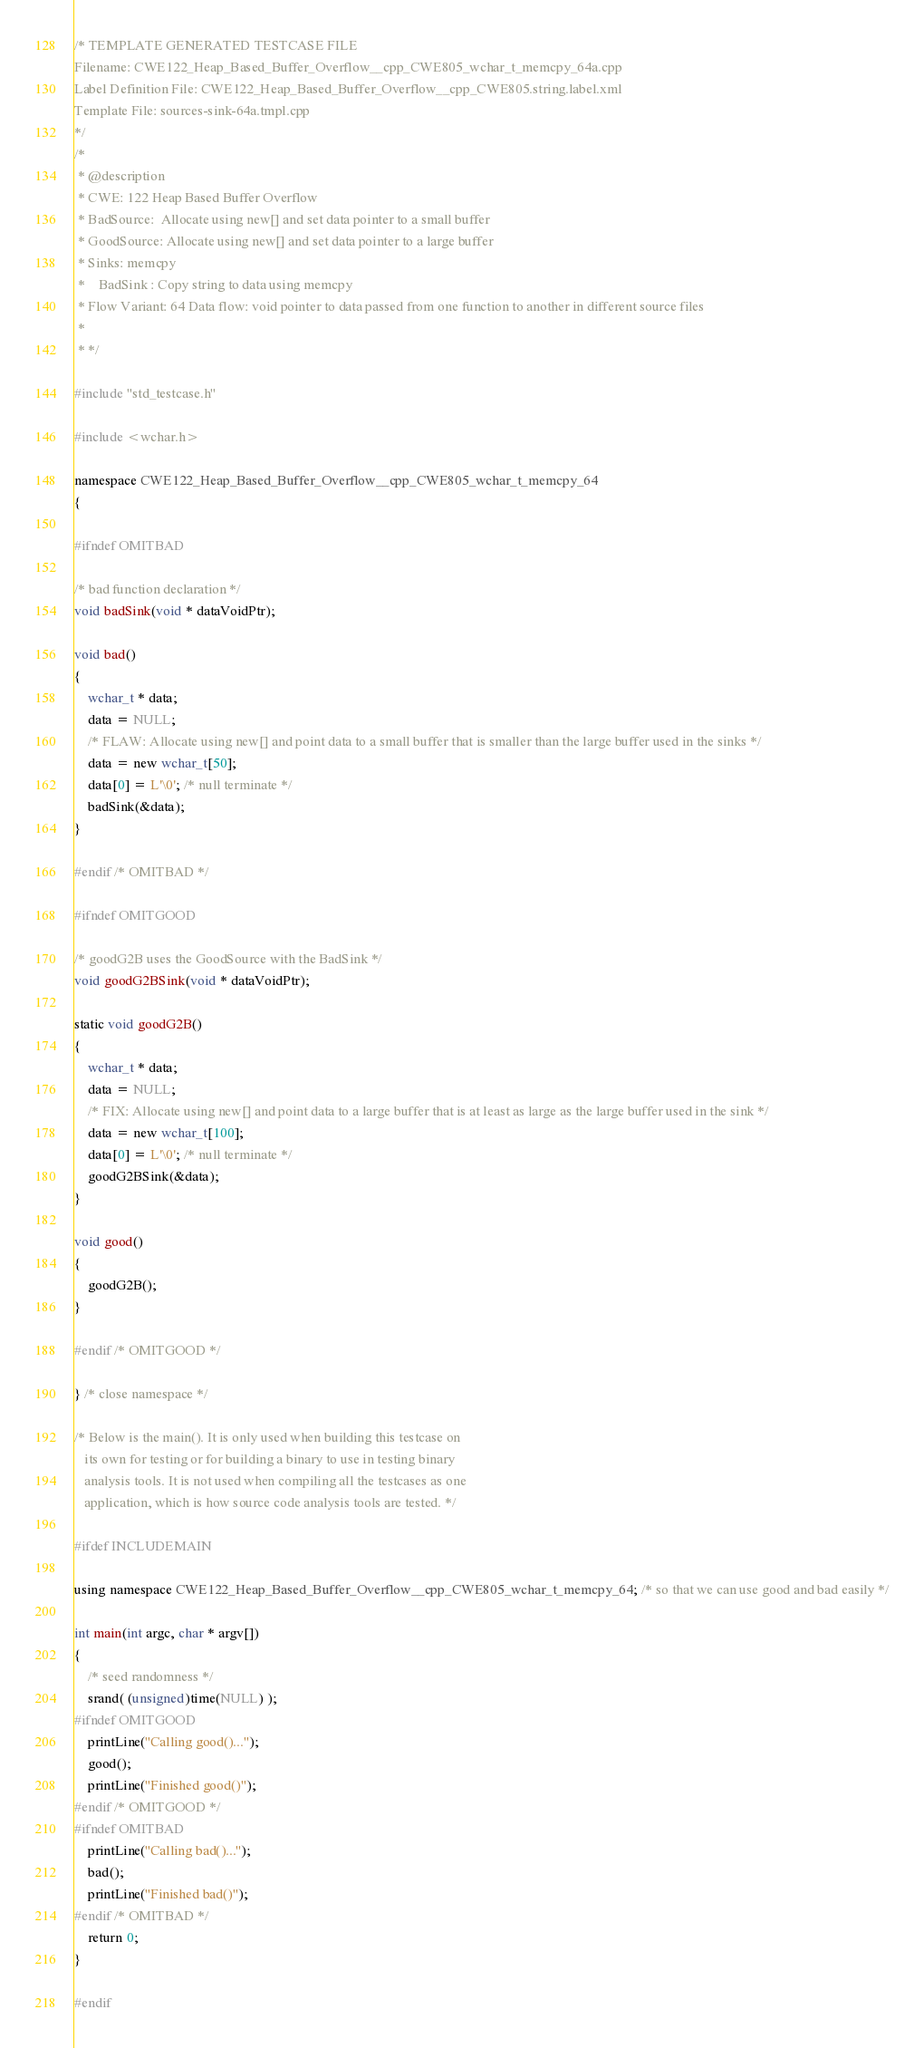<code> <loc_0><loc_0><loc_500><loc_500><_C++_>/* TEMPLATE GENERATED TESTCASE FILE
Filename: CWE122_Heap_Based_Buffer_Overflow__cpp_CWE805_wchar_t_memcpy_64a.cpp
Label Definition File: CWE122_Heap_Based_Buffer_Overflow__cpp_CWE805.string.label.xml
Template File: sources-sink-64a.tmpl.cpp
*/
/*
 * @description
 * CWE: 122 Heap Based Buffer Overflow
 * BadSource:  Allocate using new[] and set data pointer to a small buffer
 * GoodSource: Allocate using new[] and set data pointer to a large buffer
 * Sinks: memcpy
 *    BadSink : Copy string to data using memcpy
 * Flow Variant: 64 Data flow: void pointer to data passed from one function to another in different source files
 *
 * */

#include "std_testcase.h"

#include <wchar.h>

namespace CWE122_Heap_Based_Buffer_Overflow__cpp_CWE805_wchar_t_memcpy_64
{

#ifndef OMITBAD

/* bad function declaration */
void badSink(void * dataVoidPtr);

void bad()
{
    wchar_t * data;
    data = NULL;
    /* FLAW: Allocate using new[] and point data to a small buffer that is smaller than the large buffer used in the sinks */
    data = new wchar_t[50];
    data[0] = L'\0'; /* null terminate */
    badSink(&data);
}

#endif /* OMITBAD */

#ifndef OMITGOOD

/* goodG2B uses the GoodSource with the BadSink */
void goodG2BSink(void * dataVoidPtr);

static void goodG2B()
{
    wchar_t * data;
    data = NULL;
    /* FIX: Allocate using new[] and point data to a large buffer that is at least as large as the large buffer used in the sink */
    data = new wchar_t[100];
    data[0] = L'\0'; /* null terminate */
    goodG2BSink(&data);
}

void good()
{
    goodG2B();
}

#endif /* OMITGOOD */

} /* close namespace */

/* Below is the main(). It is only used when building this testcase on
   its own for testing or for building a binary to use in testing binary
   analysis tools. It is not used when compiling all the testcases as one
   application, which is how source code analysis tools are tested. */

#ifdef INCLUDEMAIN

using namespace CWE122_Heap_Based_Buffer_Overflow__cpp_CWE805_wchar_t_memcpy_64; /* so that we can use good and bad easily */

int main(int argc, char * argv[])
{
    /* seed randomness */
    srand( (unsigned)time(NULL) );
#ifndef OMITGOOD
    printLine("Calling good()...");
    good();
    printLine("Finished good()");
#endif /* OMITGOOD */
#ifndef OMITBAD
    printLine("Calling bad()...");
    bad();
    printLine("Finished bad()");
#endif /* OMITBAD */
    return 0;
}

#endif
</code> 